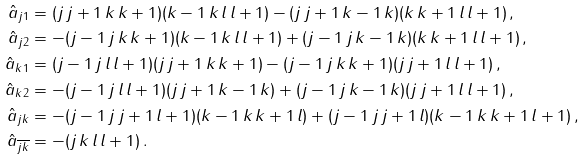<formula> <loc_0><loc_0><loc_500><loc_500>\hat { a } _ { j 1 } & = ( j \, j + 1 \, k \, k + 1 ) ( k - 1 \, k \, l \, l + 1 ) - ( j \, j + 1 \, k - 1 \, k ) ( k \, k + 1 \, l \, l + 1 ) \, , \\ \hat { a } _ { j 2 } & = - ( j - 1 \, j \, k \, k + 1 ) ( k - 1 \, k \, l \, l + 1 ) + ( j - 1 \, j \, k - 1 \, k ) ( k \, k + 1 \, l \, l + 1 ) \, , \\ \hat { a } _ { k 1 } & = ( j - 1 \, j \, l \, l + 1 ) ( j \, j + 1 \, k \, k + 1 ) - ( j - 1 \, j \, k \, k + 1 ) ( j \, j + 1 \, l \, l + 1 ) \, , \\ \hat { a } _ { k 2 } & = - ( j - 1 \, j \, l \, l + 1 ) ( j \, j + 1 \, k - 1 \, k ) + ( j - 1 \, j \, k - 1 \, k ) ( j \, j + 1 \, l \, l + 1 ) \, , \\ \hat { a } _ { j k } & = - ( j - 1 \, j \, j + 1 \, l + 1 ) ( k - 1 \, k \, k + 1 \, l ) + ( j - 1 \, j \, j + 1 \, l ) ( k - 1 \, k \, k + 1 \, l + 1 ) \, , \\ \hat { a } _ { \overline { j k } } & = - ( j \, k \, l \, l + 1 ) \, .</formula> 